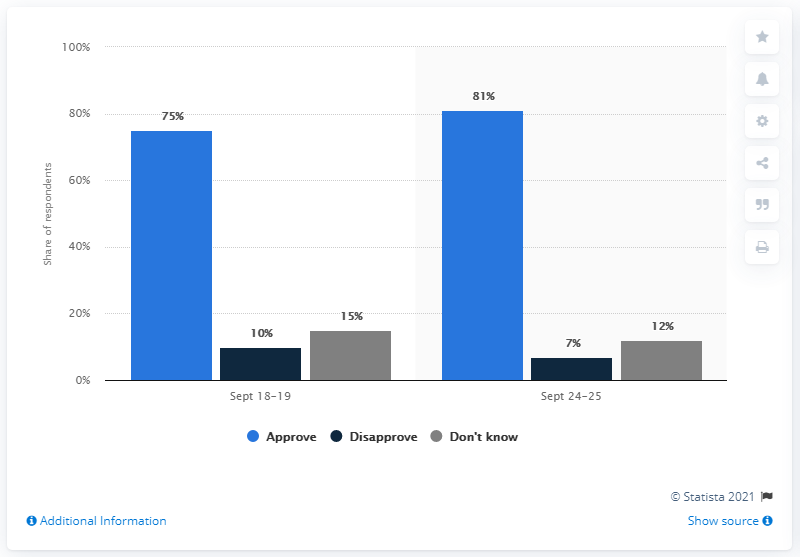Highlight a few significant elements in this photo. On September 18-19, the ratio of those who disapprove and those who don't know the jobs performance is 0.666666667. Seventy-five percent of respondents approve of RAF dropping on Sep 18-19. 